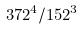Convert formula to latex. <formula><loc_0><loc_0><loc_500><loc_500>3 7 2 ^ { 4 } / 1 5 2 ^ { 3 }</formula> 